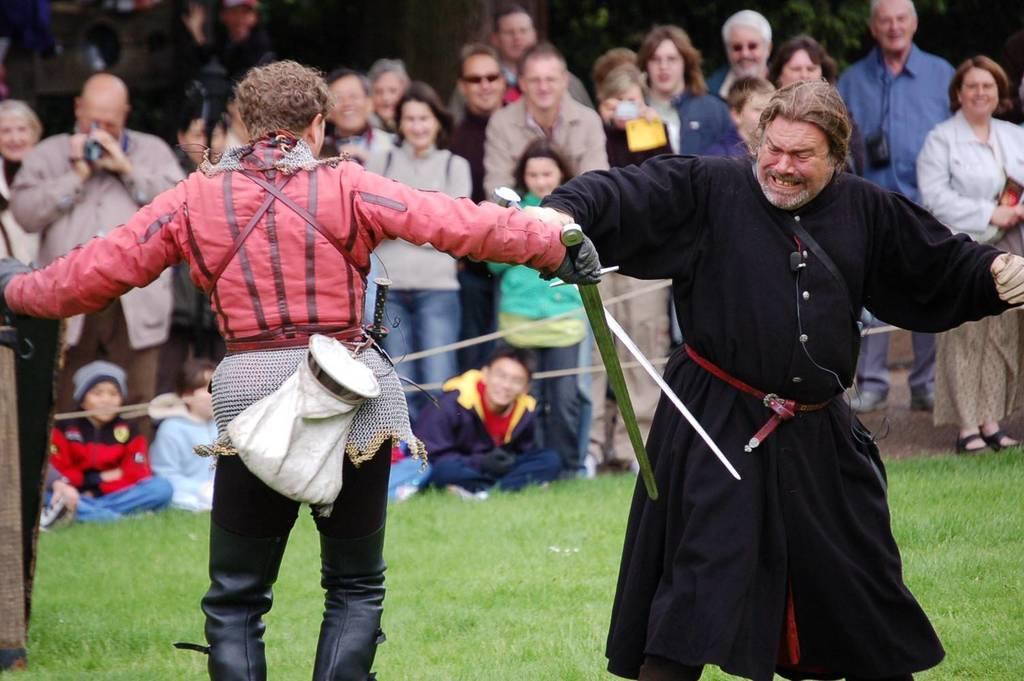Please provide a concise description of this image. In the background portion of the picture we can see people standing and sitting. We can see few are sitting and holding gadgets in their hands and recording. At the bottom we can see green grass. We can see men holding swords in their hands and fighting. 